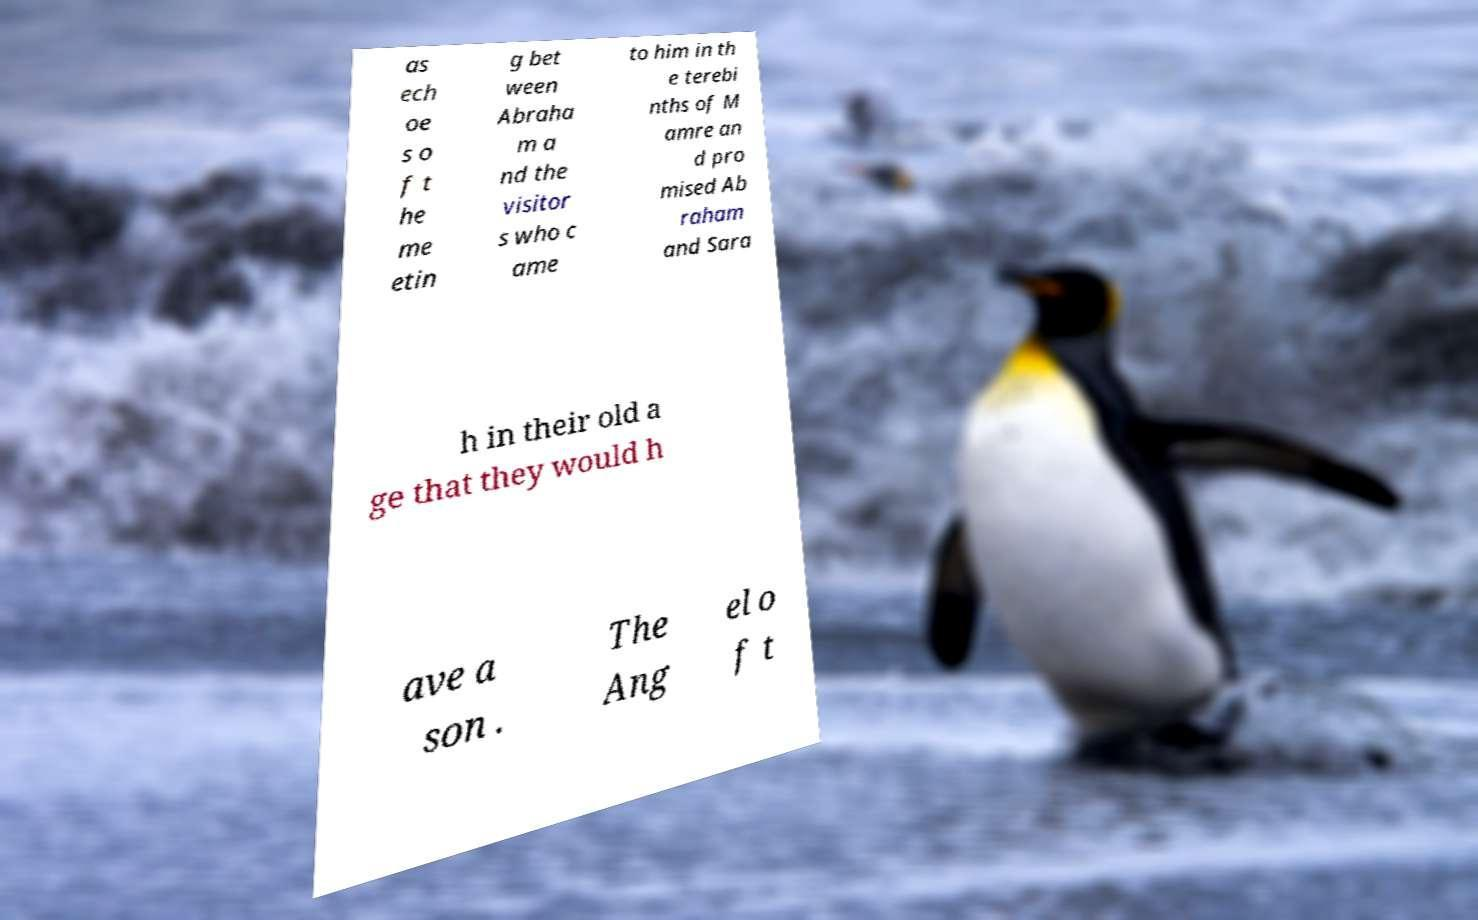What messages or text are displayed in this image? I need them in a readable, typed format. as ech oe s o f t he me etin g bet ween Abraha m a nd the visitor s who c ame to him in th e terebi nths of M amre an d pro mised Ab raham and Sara h in their old a ge that they would h ave a son . The Ang el o f t 